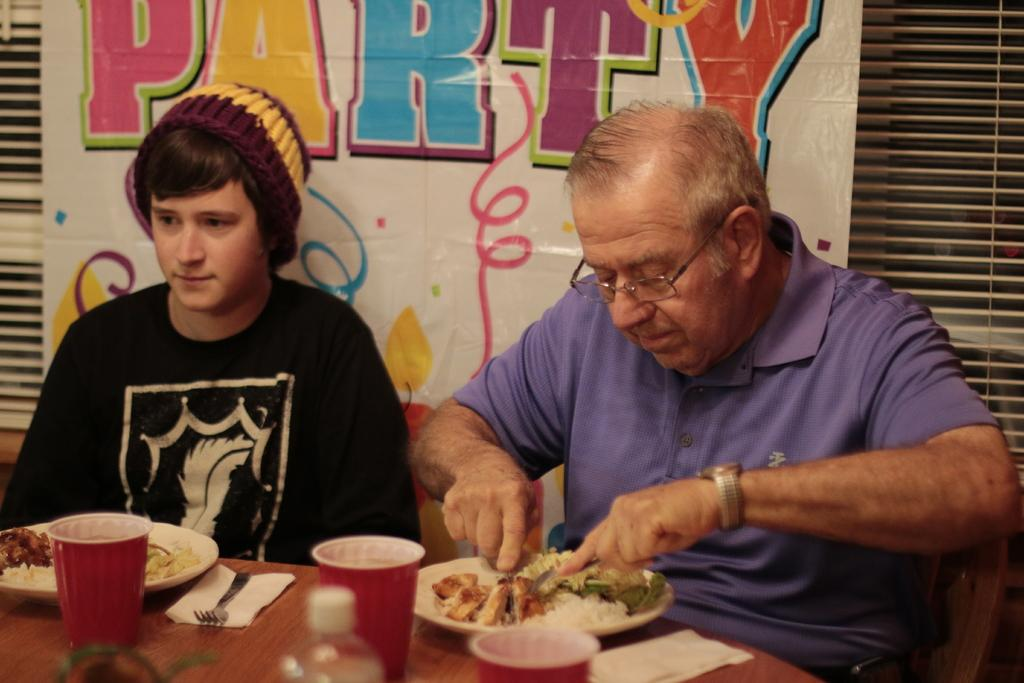Who is present in the image? There are people in the image. What is on the plates that the people are holding or eating from? There is food on plates in the image. What can be seen on the table in the image? There are objects on the table in the image. What is hanging or displayed in the image? There is a banner in the image. What is written or depicted on the banner? There is text on the banner. Where is the stove located in the image? There is no stove present in the image. What type of curve can be seen in the image? There is no curve visible in the image. 